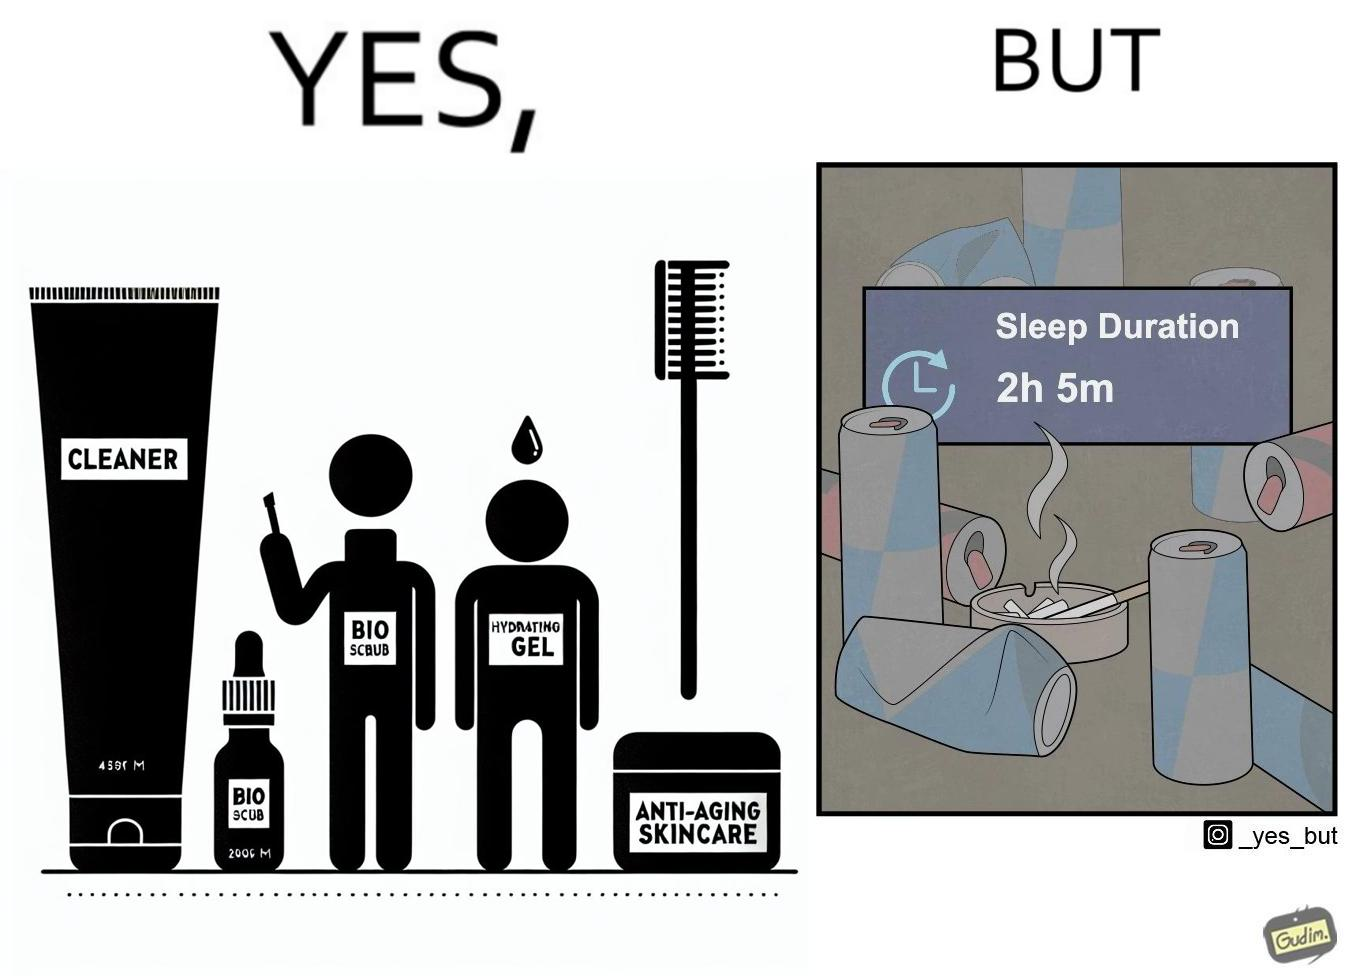Is there satirical content in this image? Yes, this image is satirical. 